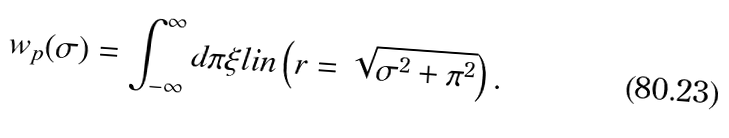<formula> <loc_0><loc_0><loc_500><loc_500>w _ { p } ( \sigma ) = \int _ { - \infty } ^ { \infty } d \pi \xi l i n \left ( r = \sqrt { \sigma ^ { 2 } + \pi ^ { 2 } } \right ) .</formula> 